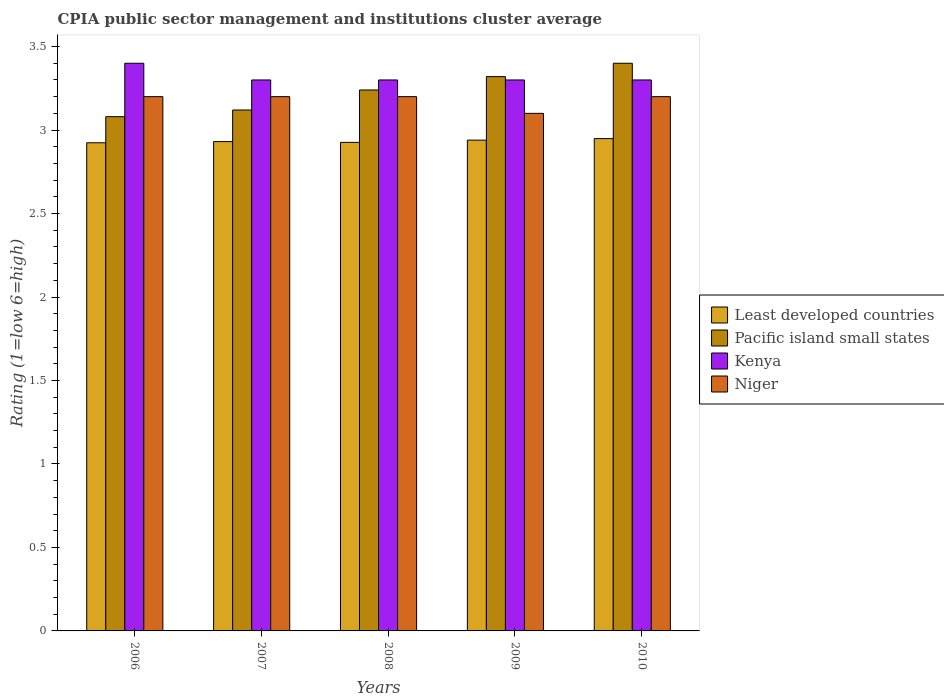How many different coloured bars are there?
Keep it short and to the point. 4. How many groups of bars are there?
Offer a very short reply. 5. Are the number of bars per tick equal to the number of legend labels?
Your response must be concise. Yes. How many bars are there on the 4th tick from the left?
Your response must be concise. 4. In how many cases, is the number of bars for a given year not equal to the number of legend labels?
Provide a succinct answer. 0. What is the CPIA rating in Least developed countries in 2009?
Give a very brief answer. 2.94. Across all years, what is the maximum CPIA rating in Kenya?
Offer a very short reply. 3.4. Across all years, what is the minimum CPIA rating in Kenya?
Make the answer very short. 3.3. In which year was the CPIA rating in Pacific island small states maximum?
Make the answer very short. 2010. What is the total CPIA rating in Pacific island small states in the graph?
Provide a succinct answer. 16.16. What is the difference between the CPIA rating in Pacific island small states in 2006 and that in 2010?
Keep it short and to the point. -0.32. What is the difference between the CPIA rating in Pacific island small states in 2008 and the CPIA rating in Niger in 2009?
Your answer should be very brief. 0.14. What is the average CPIA rating in Pacific island small states per year?
Give a very brief answer. 3.23. In the year 2007, what is the difference between the CPIA rating in Niger and CPIA rating in Least developed countries?
Keep it short and to the point. 0.27. What is the ratio of the CPIA rating in Least developed countries in 2009 to that in 2010?
Offer a very short reply. 1. Is the difference between the CPIA rating in Niger in 2009 and 2010 greater than the difference between the CPIA rating in Least developed countries in 2009 and 2010?
Your response must be concise. No. What is the difference between the highest and the second highest CPIA rating in Kenya?
Ensure brevity in your answer.  0.1. What is the difference between the highest and the lowest CPIA rating in Niger?
Make the answer very short. 0.1. Is it the case that in every year, the sum of the CPIA rating in Least developed countries and CPIA rating in Pacific island small states is greater than the sum of CPIA rating in Kenya and CPIA rating in Niger?
Your response must be concise. Yes. What does the 3rd bar from the left in 2007 represents?
Your answer should be compact. Kenya. What does the 4th bar from the right in 2006 represents?
Ensure brevity in your answer.  Least developed countries. How many bars are there?
Keep it short and to the point. 20. How many years are there in the graph?
Your answer should be compact. 5. Are the values on the major ticks of Y-axis written in scientific E-notation?
Offer a very short reply. No. Does the graph contain any zero values?
Give a very brief answer. No. Where does the legend appear in the graph?
Make the answer very short. Center right. How are the legend labels stacked?
Make the answer very short. Vertical. What is the title of the graph?
Make the answer very short. CPIA public sector management and institutions cluster average. What is the label or title of the X-axis?
Provide a succinct answer. Years. What is the label or title of the Y-axis?
Offer a very short reply. Rating (1=low 6=high). What is the Rating (1=low 6=high) in Least developed countries in 2006?
Your response must be concise. 2.92. What is the Rating (1=low 6=high) in Pacific island small states in 2006?
Your answer should be very brief. 3.08. What is the Rating (1=low 6=high) in Kenya in 2006?
Ensure brevity in your answer.  3.4. What is the Rating (1=low 6=high) in Niger in 2006?
Your answer should be compact. 3.2. What is the Rating (1=low 6=high) of Least developed countries in 2007?
Make the answer very short. 2.93. What is the Rating (1=low 6=high) in Pacific island small states in 2007?
Provide a succinct answer. 3.12. What is the Rating (1=low 6=high) in Least developed countries in 2008?
Give a very brief answer. 2.93. What is the Rating (1=low 6=high) of Pacific island small states in 2008?
Make the answer very short. 3.24. What is the Rating (1=low 6=high) in Niger in 2008?
Offer a terse response. 3.2. What is the Rating (1=low 6=high) of Least developed countries in 2009?
Give a very brief answer. 2.94. What is the Rating (1=low 6=high) in Pacific island small states in 2009?
Provide a short and direct response. 3.32. What is the Rating (1=low 6=high) of Niger in 2009?
Your answer should be very brief. 3.1. What is the Rating (1=low 6=high) of Least developed countries in 2010?
Keep it short and to the point. 2.95. Across all years, what is the maximum Rating (1=low 6=high) of Least developed countries?
Give a very brief answer. 2.95. Across all years, what is the maximum Rating (1=low 6=high) of Kenya?
Your answer should be very brief. 3.4. Across all years, what is the minimum Rating (1=low 6=high) in Least developed countries?
Your answer should be very brief. 2.92. Across all years, what is the minimum Rating (1=low 6=high) in Pacific island small states?
Provide a succinct answer. 3.08. What is the total Rating (1=low 6=high) of Least developed countries in the graph?
Your answer should be very brief. 14.67. What is the total Rating (1=low 6=high) in Pacific island small states in the graph?
Make the answer very short. 16.16. What is the difference between the Rating (1=low 6=high) in Least developed countries in 2006 and that in 2007?
Your response must be concise. -0.01. What is the difference between the Rating (1=low 6=high) of Pacific island small states in 2006 and that in 2007?
Offer a very short reply. -0.04. What is the difference between the Rating (1=low 6=high) of Kenya in 2006 and that in 2007?
Offer a very short reply. 0.1. What is the difference between the Rating (1=low 6=high) of Niger in 2006 and that in 2007?
Provide a succinct answer. 0. What is the difference between the Rating (1=low 6=high) of Least developed countries in 2006 and that in 2008?
Provide a short and direct response. -0. What is the difference between the Rating (1=low 6=high) of Pacific island small states in 2006 and that in 2008?
Your answer should be very brief. -0.16. What is the difference between the Rating (1=low 6=high) in Kenya in 2006 and that in 2008?
Offer a terse response. 0.1. What is the difference between the Rating (1=low 6=high) of Niger in 2006 and that in 2008?
Offer a terse response. 0. What is the difference between the Rating (1=low 6=high) of Least developed countries in 2006 and that in 2009?
Provide a succinct answer. -0.02. What is the difference between the Rating (1=low 6=high) of Pacific island small states in 2006 and that in 2009?
Keep it short and to the point. -0.24. What is the difference between the Rating (1=low 6=high) of Kenya in 2006 and that in 2009?
Your answer should be very brief. 0.1. What is the difference between the Rating (1=low 6=high) in Least developed countries in 2006 and that in 2010?
Provide a short and direct response. -0.03. What is the difference between the Rating (1=low 6=high) in Pacific island small states in 2006 and that in 2010?
Your answer should be compact. -0.32. What is the difference between the Rating (1=low 6=high) of Least developed countries in 2007 and that in 2008?
Provide a succinct answer. 0. What is the difference between the Rating (1=low 6=high) in Pacific island small states in 2007 and that in 2008?
Provide a short and direct response. -0.12. What is the difference between the Rating (1=low 6=high) of Niger in 2007 and that in 2008?
Provide a short and direct response. 0. What is the difference between the Rating (1=low 6=high) in Least developed countries in 2007 and that in 2009?
Make the answer very short. -0.01. What is the difference between the Rating (1=low 6=high) in Kenya in 2007 and that in 2009?
Ensure brevity in your answer.  0. What is the difference between the Rating (1=low 6=high) in Least developed countries in 2007 and that in 2010?
Give a very brief answer. -0.02. What is the difference between the Rating (1=low 6=high) of Pacific island small states in 2007 and that in 2010?
Provide a succinct answer. -0.28. What is the difference between the Rating (1=low 6=high) in Niger in 2007 and that in 2010?
Your answer should be very brief. 0. What is the difference between the Rating (1=low 6=high) in Least developed countries in 2008 and that in 2009?
Provide a short and direct response. -0.01. What is the difference between the Rating (1=low 6=high) in Pacific island small states in 2008 and that in 2009?
Your answer should be very brief. -0.08. What is the difference between the Rating (1=low 6=high) in Least developed countries in 2008 and that in 2010?
Give a very brief answer. -0.02. What is the difference between the Rating (1=low 6=high) in Pacific island small states in 2008 and that in 2010?
Keep it short and to the point. -0.16. What is the difference between the Rating (1=low 6=high) in Niger in 2008 and that in 2010?
Give a very brief answer. 0. What is the difference between the Rating (1=low 6=high) of Least developed countries in 2009 and that in 2010?
Your answer should be compact. -0.01. What is the difference between the Rating (1=low 6=high) of Pacific island small states in 2009 and that in 2010?
Offer a terse response. -0.08. What is the difference between the Rating (1=low 6=high) of Kenya in 2009 and that in 2010?
Ensure brevity in your answer.  0. What is the difference between the Rating (1=low 6=high) in Niger in 2009 and that in 2010?
Your answer should be very brief. -0.1. What is the difference between the Rating (1=low 6=high) of Least developed countries in 2006 and the Rating (1=low 6=high) of Pacific island small states in 2007?
Your answer should be compact. -0.2. What is the difference between the Rating (1=low 6=high) in Least developed countries in 2006 and the Rating (1=low 6=high) in Kenya in 2007?
Provide a short and direct response. -0.38. What is the difference between the Rating (1=low 6=high) of Least developed countries in 2006 and the Rating (1=low 6=high) of Niger in 2007?
Offer a terse response. -0.28. What is the difference between the Rating (1=low 6=high) of Pacific island small states in 2006 and the Rating (1=low 6=high) of Kenya in 2007?
Give a very brief answer. -0.22. What is the difference between the Rating (1=low 6=high) of Pacific island small states in 2006 and the Rating (1=low 6=high) of Niger in 2007?
Make the answer very short. -0.12. What is the difference between the Rating (1=low 6=high) of Least developed countries in 2006 and the Rating (1=low 6=high) of Pacific island small states in 2008?
Your response must be concise. -0.32. What is the difference between the Rating (1=low 6=high) of Least developed countries in 2006 and the Rating (1=low 6=high) of Kenya in 2008?
Your response must be concise. -0.38. What is the difference between the Rating (1=low 6=high) of Least developed countries in 2006 and the Rating (1=low 6=high) of Niger in 2008?
Offer a terse response. -0.28. What is the difference between the Rating (1=low 6=high) of Pacific island small states in 2006 and the Rating (1=low 6=high) of Kenya in 2008?
Provide a succinct answer. -0.22. What is the difference between the Rating (1=low 6=high) of Pacific island small states in 2006 and the Rating (1=low 6=high) of Niger in 2008?
Keep it short and to the point. -0.12. What is the difference between the Rating (1=low 6=high) in Kenya in 2006 and the Rating (1=low 6=high) in Niger in 2008?
Give a very brief answer. 0.2. What is the difference between the Rating (1=low 6=high) of Least developed countries in 2006 and the Rating (1=low 6=high) of Pacific island small states in 2009?
Provide a succinct answer. -0.4. What is the difference between the Rating (1=low 6=high) of Least developed countries in 2006 and the Rating (1=low 6=high) of Kenya in 2009?
Offer a terse response. -0.38. What is the difference between the Rating (1=low 6=high) of Least developed countries in 2006 and the Rating (1=low 6=high) of Niger in 2009?
Keep it short and to the point. -0.18. What is the difference between the Rating (1=low 6=high) of Pacific island small states in 2006 and the Rating (1=low 6=high) of Kenya in 2009?
Provide a short and direct response. -0.22. What is the difference between the Rating (1=low 6=high) of Pacific island small states in 2006 and the Rating (1=low 6=high) of Niger in 2009?
Your response must be concise. -0.02. What is the difference between the Rating (1=low 6=high) in Kenya in 2006 and the Rating (1=low 6=high) in Niger in 2009?
Give a very brief answer. 0.3. What is the difference between the Rating (1=low 6=high) of Least developed countries in 2006 and the Rating (1=low 6=high) of Pacific island small states in 2010?
Your answer should be very brief. -0.48. What is the difference between the Rating (1=low 6=high) in Least developed countries in 2006 and the Rating (1=low 6=high) in Kenya in 2010?
Keep it short and to the point. -0.38. What is the difference between the Rating (1=low 6=high) in Least developed countries in 2006 and the Rating (1=low 6=high) in Niger in 2010?
Give a very brief answer. -0.28. What is the difference between the Rating (1=low 6=high) in Pacific island small states in 2006 and the Rating (1=low 6=high) in Kenya in 2010?
Provide a short and direct response. -0.22. What is the difference between the Rating (1=low 6=high) in Pacific island small states in 2006 and the Rating (1=low 6=high) in Niger in 2010?
Make the answer very short. -0.12. What is the difference between the Rating (1=low 6=high) in Least developed countries in 2007 and the Rating (1=low 6=high) in Pacific island small states in 2008?
Offer a terse response. -0.31. What is the difference between the Rating (1=low 6=high) in Least developed countries in 2007 and the Rating (1=low 6=high) in Kenya in 2008?
Your response must be concise. -0.37. What is the difference between the Rating (1=low 6=high) in Least developed countries in 2007 and the Rating (1=low 6=high) in Niger in 2008?
Provide a succinct answer. -0.27. What is the difference between the Rating (1=low 6=high) in Pacific island small states in 2007 and the Rating (1=low 6=high) in Kenya in 2008?
Offer a very short reply. -0.18. What is the difference between the Rating (1=low 6=high) in Pacific island small states in 2007 and the Rating (1=low 6=high) in Niger in 2008?
Offer a terse response. -0.08. What is the difference between the Rating (1=low 6=high) of Least developed countries in 2007 and the Rating (1=low 6=high) of Pacific island small states in 2009?
Provide a succinct answer. -0.39. What is the difference between the Rating (1=low 6=high) in Least developed countries in 2007 and the Rating (1=low 6=high) in Kenya in 2009?
Your answer should be very brief. -0.37. What is the difference between the Rating (1=low 6=high) in Least developed countries in 2007 and the Rating (1=low 6=high) in Niger in 2009?
Your answer should be compact. -0.17. What is the difference between the Rating (1=low 6=high) in Pacific island small states in 2007 and the Rating (1=low 6=high) in Kenya in 2009?
Provide a succinct answer. -0.18. What is the difference between the Rating (1=low 6=high) in Kenya in 2007 and the Rating (1=low 6=high) in Niger in 2009?
Ensure brevity in your answer.  0.2. What is the difference between the Rating (1=low 6=high) in Least developed countries in 2007 and the Rating (1=low 6=high) in Pacific island small states in 2010?
Make the answer very short. -0.47. What is the difference between the Rating (1=low 6=high) in Least developed countries in 2007 and the Rating (1=low 6=high) in Kenya in 2010?
Give a very brief answer. -0.37. What is the difference between the Rating (1=low 6=high) in Least developed countries in 2007 and the Rating (1=low 6=high) in Niger in 2010?
Ensure brevity in your answer.  -0.27. What is the difference between the Rating (1=low 6=high) in Pacific island small states in 2007 and the Rating (1=low 6=high) in Kenya in 2010?
Your answer should be very brief. -0.18. What is the difference between the Rating (1=low 6=high) in Pacific island small states in 2007 and the Rating (1=low 6=high) in Niger in 2010?
Make the answer very short. -0.08. What is the difference between the Rating (1=low 6=high) of Kenya in 2007 and the Rating (1=low 6=high) of Niger in 2010?
Keep it short and to the point. 0.1. What is the difference between the Rating (1=low 6=high) of Least developed countries in 2008 and the Rating (1=low 6=high) of Pacific island small states in 2009?
Your response must be concise. -0.39. What is the difference between the Rating (1=low 6=high) in Least developed countries in 2008 and the Rating (1=low 6=high) in Kenya in 2009?
Offer a terse response. -0.37. What is the difference between the Rating (1=low 6=high) of Least developed countries in 2008 and the Rating (1=low 6=high) of Niger in 2009?
Ensure brevity in your answer.  -0.17. What is the difference between the Rating (1=low 6=high) of Pacific island small states in 2008 and the Rating (1=low 6=high) of Kenya in 2009?
Your answer should be compact. -0.06. What is the difference between the Rating (1=low 6=high) of Pacific island small states in 2008 and the Rating (1=low 6=high) of Niger in 2009?
Your answer should be very brief. 0.14. What is the difference between the Rating (1=low 6=high) in Kenya in 2008 and the Rating (1=low 6=high) in Niger in 2009?
Keep it short and to the point. 0.2. What is the difference between the Rating (1=low 6=high) in Least developed countries in 2008 and the Rating (1=low 6=high) in Pacific island small states in 2010?
Keep it short and to the point. -0.47. What is the difference between the Rating (1=low 6=high) of Least developed countries in 2008 and the Rating (1=low 6=high) of Kenya in 2010?
Your answer should be compact. -0.37. What is the difference between the Rating (1=low 6=high) in Least developed countries in 2008 and the Rating (1=low 6=high) in Niger in 2010?
Keep it short and to the point. -0.27. What is the difference between the Rating (1=low 6=high) of Pacific island small states in 2008 and the Rating (1=low 6=high) of Kenya in 2010?
Your response must be concise. -0.06. What is the difference between the Rating (1=low 6=high) in Pacific island small states in 2008 and the Rating (1=low 6=high) in Niger in 2010?
Give a very brief answer. 0.04. What is the difference between the Rating (1=low 6=high) of Least developed countries in 2009 and the Rating (1=low 6=high) of Pacific island small states in 2010?
Give a very brief answer. -0.46. What is the difference between the Rating (1=low 6=high) of Least developed countries in 2009 and the Rating (1=low 6=high) of Kenya in 2010?
Your answer should be very brief. -0.36. What is the difference between the Rating (1=low 6=high) in Least developed countries in 2009 and the Rating (1=low 6=high) in Niger in 2010?
Make the answer very short. -0.26. What is the difference between the Rating (1=low 6=high) of Pacific island small states in 2009 and the Rating (1=low 6=high) of Niger in 2010?
Make the answer very short. 0.12. What is the difference between the Rating (1=low 6=high) in Kenya in 2009 and the Rating (1=low 6=high) in Niger in 2010?
Provide a succinct answer. 0.1. What is the average Rating (1=low 6=high) of Least developed countries per year?
Give a very brief answer. 2.93. What is the average Rating (1=low 6=high) in Pacific island small states per year?
Offer a terse response. 3.23. What is the average Rating (1=low 6=high) of Kenya per year?
Offer a terse response. 3.32. What is the average Rating (1=low 6=high) of Niger per year?
Make the answer very short. 3.18. In the year 2006, what is the difference between the Rating (1=low 6=high) in Least developed countries and Rating (1=low 6=high) in Pacific island small states?
Your answer should be compact. -0.16. In the year 2006, what is the difference between the Rating (1=low 6=high) of Least developed countries and Rating (1=low 6=high) of Kenya?
Your answer should be very brief. -0.48. In the year 2006, what is the difference between the Rating (1=low 6=high) in Least developed countries and Rating (1=low 6=high) in Niger?
Your response must be concise. -0.28. In the year 2006, what is the difference between the Rating (1=low 6=high) of Pacific island small states and Rating (1=low 6=high) of Kenya?
Offer a very short reply. -0.32. In the year 2006, what is the difference between the Rating (1=low 6=high) of Pacific island small states and Rating (1=low 6=high) of Niger?
Keep it short and to the point. -0.12. In the year 2007, what is the difference between the Rating (1=low 6=high) of Least developed countries and Rating (1=low 6=high) of Pacific island small states?
Make the answer very short. -0.19. In the year 2007, what is the difference between the Rating (1=low 6=high) in Least developed countries and Rating (1=low 6=high) in Kenya?
Provide a short and direct response. -0.37. In the year 2007, what is the difference between the Rating (1=low 6=high) in Least developed countries and Rating (1=low 6=high) in Niger?
Ensure brevity in your answer.  -0.27. In the year 2007, what is the difference between the Rating (1=low 6=high) of Pacific island small states and Rating (1=low 6=high) of Kenya?
Offer a very short reply. -0.18. In the year 2007, what is the difference between the Rating (1=low 6=high) in Pacific island small states and Rating (1=low 6=high) in Niger?
Your answer should be very brief. -0.08. In the year 2008, what is the difference between the Rating (1=low 6=high) in Least developed countries and Rating (1=low 6=high) in Pacific island small states?
Keep it short and to the point. -0.31. In the year 2008, what is the difference between the Rating (1=low 6=high) in Least developed countries and Rating (1=low 6=high) in Kenya?
Your answer should be compact. -0.37. In the year 2008, what is the difference between the Rating (1=low 6=high) in Least developed countries and Rating (1=low 6=high) in Niger?
Provide a succinct answer. -0.27. In the year 2008, what is the difference between the Rating (1=low 6=high) in Pacific island small states and Rating (1=low 6=high) in Kenya?
Offer a terse response. -0.06. In the year 2008, what is the difference between the Rating (1=low 6=high) in Pacific island small states and Rating (1=low 6=high) in Niger?
Keep it short and to the point. 0.04. In the year 2008, what is the difference between the Rating (1=low 6=high) of Kenya and Rating (1=low 6=high) of Niger?
Your answer should be very brief. 0.1. In the year 2009, what is the difference between the Rating (1=low 6=high) of Least developed countries and Rating (1=low 6=high) of Pacific island small states?
Give a very brief answer. -0.38. In the year 2009, what is the difference between the Rating (1=low 6=high) in Least developed countries and Rating (1=low 6=high) in Kenya?
Offer a terse response. -0.36. In the year 2009, what is the difference between the Rating (1=low 6=high) of Least developed countries and Rating (1=low 6=high) of Niger?
Give a very brief answer. -0.16. In the year 2009, what is the difference between the Rating (1=low 6=high) of Pacific island small states and Rating (1=low 6=high) of Kenya?
Ensure brevity in your answer.  0.02. In the year 2009, what is the difference between the Rating (1=low 6=high) in Pacific island small states and Rating (1=low 6=high) in Niger?
Keep it short and to the point. 0.22. In the year 2010, what is the difference between the Rating (1=low 6=high) of Least developed countries and Rating (1=low 6=high) of Pacific island small states?
Offer a very short reply. -0.45. In the year 2010, what is the difference between the Rating (1=low 6=high) of Least developed countries and Rating (1=low 6=high) of Kenya?
Your response must be concise. -0.35. In the year 2010, what is the difference between the Rating (1=low 6=high) in Least developed countries and Rating (1=low 6=high) in Niger?
Make the answer very short. -0.25. What is the ratio of the Rating (1=low 6=high) of Least developed countries in 2006 to that in 2007?
Offer a terse response. 1. What is the ratio of the Rating (1=low 6=high) in Pacific island small states in 2006 to that in 2007?
Give a very brief answer. 0.99. What is the ratio of the Rating (1=low 6=high) in Kenya in 2006 to that in 2007?
Give a very brief answer. 1.03. What is the ratio of the Rating (1=low 6=high) in Least developed countries in 2006 to that in 2008?
Provide a short and direct response. 1. What is the ratio of the Rating (1=low 6=high) in Pacific island small states in 2006 to that in 2008?
Offer a very short reply. 0.95. What is the ratio of the Rating (1=low 6=high) of Kenya in 2006 to that in 2008?
Offer a very short reply. 1.03. What is the ratio of the Rating (1=low 6=high) of Pacific island small states in 2006 to that in 2009?
Give a very brief answer. 0.93. What is the ratio of the Rating (1=low 6=high) in Kenya in 2006 to that in 2009?
Provide a succinct answer. 1.03. What is the ratio of the Rating (1=low 6=high) in Niger in 2006 to that in 2009?
Give a very brief answer. 1.03. What is the ratio of the Rating (1=low 6=high) of Pacific island small states in 2006 to that in 2010?
Provide a succinct answer. 0.91. What is the ratio of the Rating (1=low 6=high) of Kenya in 2006 to that in 2010?
Keep it short and to the point. 1.03. What is the ratio of the Rating (1=low 6=high) of Niger in 2006 to that in 2010?
Provide a short and direct response. 1. What is the ratio of the Rating (1=low 6=high) of Least developed countries in 2007 to that in 2008?
Provide a short and direct response. 1. What is the ratio of the Rating (1=low 6=high) of Pacific island small states in 2007 to that in 2008?
Ensure brevity in your answer.  0.96. What is the ratio of the Rating (1=low 6=high) in Kenya in 2007 to that in 2008?
Provide a succinct answer. 1. What is the ratio of the Rating (1=low 6=high) of Niger in 2007 to that in 2008?
Provide a short and direct response. 1. What is the ratio of the Rating (1=low 6=high) of Pacific island small states in 2007 to that in 2009?
Your answer should be compact. 0.94. What is the ratio of the Rating (1=low 6=high) in Niger in 2007 to that in 2009?
Your answer should be compact. 1.03. What is the ratio of the Rating (1=low 6=high) of Pacific island small states in 2007 to that in 2010?
Make the answer very short. 0.92. What is the ratio of the Rating (1=low 6=high) in Kenya in 2007 to that in 2010?
Offer a terse response. 1. What is the ratio of the Rating (1=low 6=high) in Niger in 2007 to that in 2010?
Offer a terse response. 1. What is the ratio of the Rating (1=low 6=high) of Pacific island small states in 2008 to that in 2009?
Offer a terse response. 0.98. What is the ratio of the Rating (1=low 6=high) of Niger in 2008 to that in 2009?
Make the answer very short. 1.03. What is the ratio of the Rating (1=low 6=high) in Pacific island small states in 2008 to that in 2010?
Offer a terse response. 0.95. What is the ratio of the Rating (1=low 6=high) in Kenya in 2008 to that in 2010?
Provide a short and direct response. 1. What is the ratio of the Rating (1=low 6=high) of Least developed countries in 2009 to that in 2010?
Your response must be concise. 1. What is the ratio of the Rating (1=low 6=high) of Pacific island small states in 2009 to that in 2010?
Ensure brevity in your answer.  0.98. What is the ratio of the Rating (1=low 6=high) of Kenya in 2009 to that in 2010?
Ensure brevity in your answer.  1. What is the ratio of the Rating (1=low 6=high) in Niger in 2009 to that in 2010?
Ensure brevity in your answer.  0.97. What is the difference between the highest and the second highest Rating (1=low 6=high) in Least developed countries?
Your response must be concise. 0.01. What is the difference between the highest and the lowest Rating (1=low 6=high) in Least developed countries?
Give a very brief answer. 0.03. What is the difference between the highest and the lowest Rating (1=low 6=high) in Pacific island small states?
Offer a very short reply. 0.32. What is the difference between the highest and the lowest Rating (1=low 6=high) of Niger?
Provide a short and direct response. 0.1. 